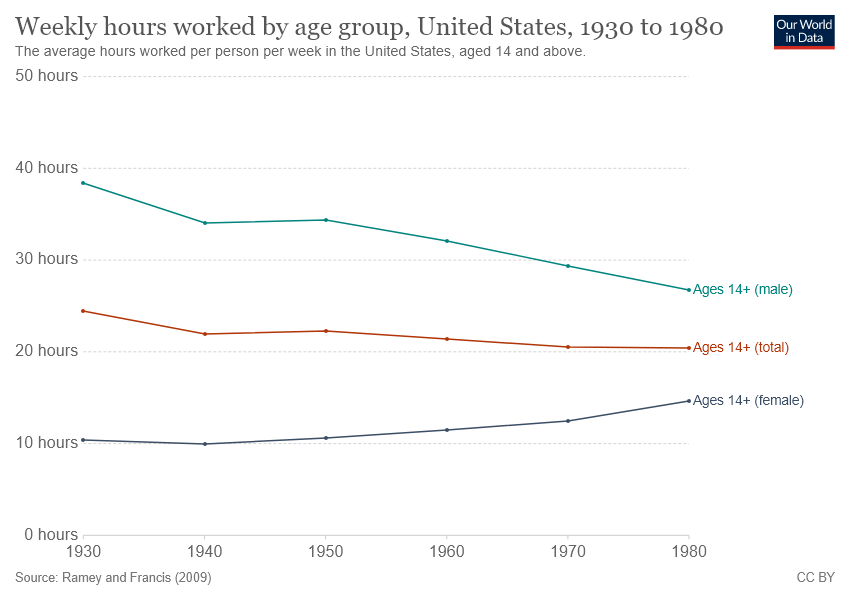Outline some significant characteristics in this image. The year that recorded the highest number of weekly hours worked by females over the years was 1980. In the year 1930, males worked the most weekly hours out of all the years in the record. 